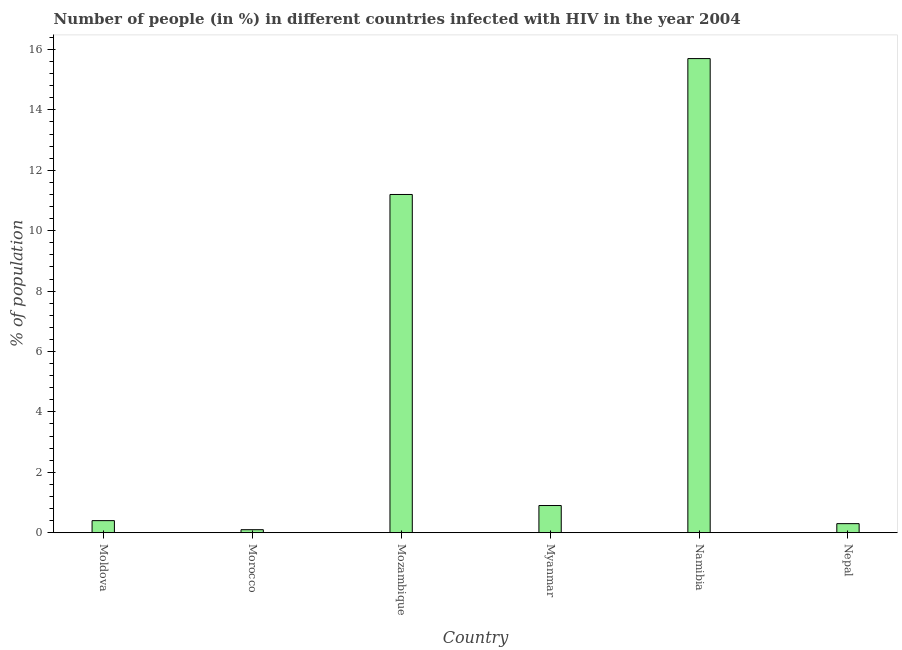What is the title of the graph?
Offer a terse response. Number of people (in %) in different countries infected with HIV in the year 2004. What is the label or title of the X-axis?
Offer a terse response. Country. What is the label or title of the Y-axis?
Give a very brief answer. % of population. What is the number of people infected with hiv in Myanmar?
Give a very brief answer. 0.9. In which country was the number of people infected with hiv maximum?
Keep it short and to the point. Namibia. In which country was the number of people infected with hiv minimum?
Provide a short and direct response. Morocco. What is the sum of the number of people infected with hiv?
Keep it short and to the point. 28.6. What is the difference between the number of people infected with hiv in Myanmar and Nepal?
Give a very brief answer. 0.6. What is the average number of people infected with hiv per country?
Make the answer very short. 4.77. What is the median number of people infected with hiv?
Your answer should be very brief. 0.65. What is the ratio of the number of people infected with hiv in Namibia to that in Nepal?
Keep it short and to the point. 52.33. Is the difference between the number of people infected with hiv in Morocco and Namibia greater than the difference between any two countries?
Keep it short and to the point. Yes. What is the difference between the highest and the second highest number of people infected with hiv?
Your answer should be very brief. 4.5. Is the sum of the number of people infected with hiv in Mozambique and Myanmar greater than the maximum number of people infected with hiv across all countries?
Offer a terse response. No. Are the values on the major ticks of Y-axis written in scientific E-notation?
Offer a very short reply. No. What is the % of population of Mozambique?
Provide a succinct answer. 11.2. What is the % of population of Namibia?
Ensure brevity in your answer.  15.7. What is the % of population of Nepal?
Offer a very short reply. 0.3. What is the difference between the % of population in Moldova and Morocco?
Ensure brevity in your answer.  0.3. What is the difference between the % of population in Moldova and Mozambique?
Ensure brevity in your answer.  -10.8. What is the difference between the % of population in Moldova and Namibia?
Ensure brevity in your answer.  -15.3. What is the difference between the % of population in Moldova and Nepal?
Offer a very short reply. 0.1. What is the difference between the % of population in Morocco and Namibia?
Your answer should be very brief. -15.6. What is the difference between the % of population in Morocco and Nepal?
Provide a succinct answer. -0.2. What is the difference between the % of population in Mozambique and Namibia?
Offer a terse response. -4.5. What is the difference between the % of population in Mozambique and Nepal?
Your response must be concise. 10.9. What is the difference between the % of population in Myanmar and Namibia?
Your response must be concise. -14.8. What is the ratio of the % of population in Moldova to that in Mozambique?
Offer a terse response. 0.04. What is the ratio of the % of population in Moldova to that in Myanmar?
Give a very brief answer. 0.44. What is the ratio of the % of population in Moldova to that in Namibia?
Offer a terse response. 0.03. What is the ratio of the % of population in Moldova to that in Nepal?
Provide a succinct answer. 1.33. What is the ratio of the % of population in Morocco to that in Mozambique?
Make the answer very short. 0.01. What is the ratio of the % of population in Morocco to that in Myanmar?
Ensure brevity in your answer.  0.11. What is the ratio of the % of population in Morocco to that in Namibia?
Keep it short and to the point. 0.01. What is the ratio of the % of population in Morocco to that in Nepal?
Offer a very short reply. 0.33. What is the ratio of the % of population in Mozambique to that in Myanmar?
Provide a short and direct response. 12.44. What is the ratio of the % of population in Mozambique to that in Namibia?
Keep it short and to the point. 0.71. What is the ratio of the % of population in Mozambique to that in Nepal?
Provide a short and direct response. 37.33. What is the ratio of the % of population in Myanmar to that in Namibia?
Provide a short and direct response. 0.06. What is the ratio of the % of population in Myanmar to that in Nepal?
Offer a very short reply. 3. What is the ratio of the % of population in Namibia to that in Nepal?
Your response must be concise. 52.33. 